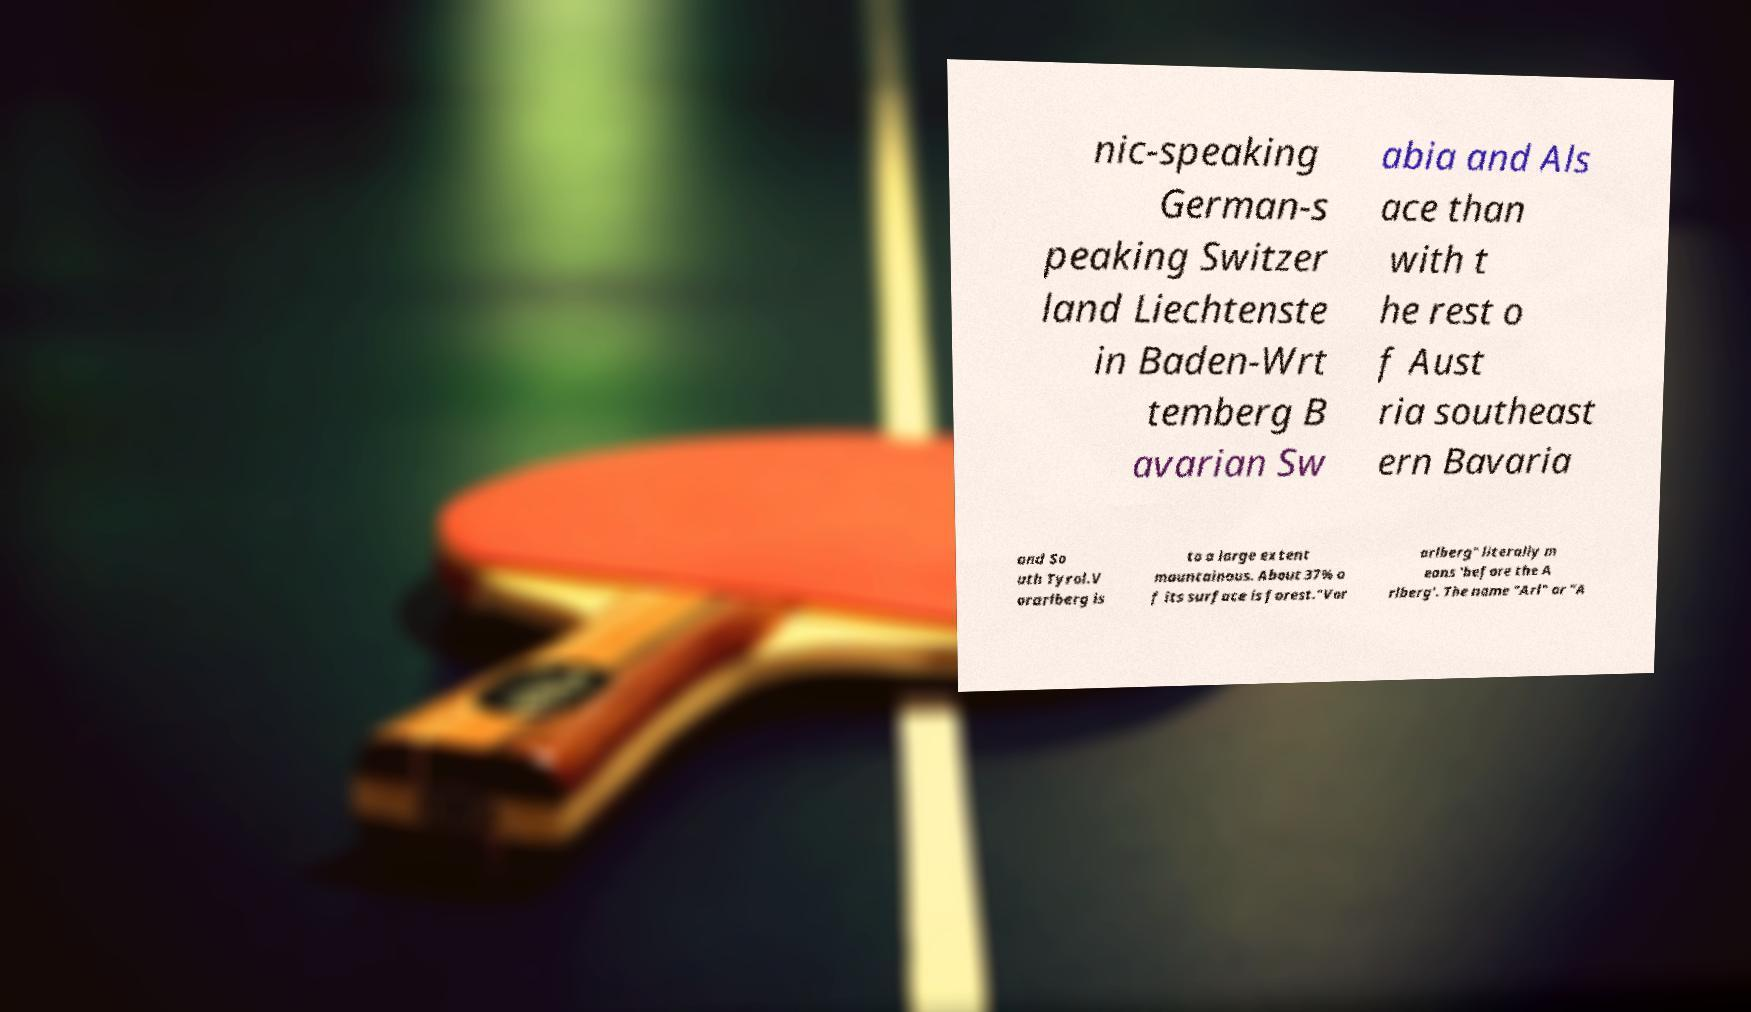Please read and relay the text visible in this image. What does it say? nic-speaking German-s peaking Switzer land Liechtenste in Baden-Wrt temberg B avarian Sw abia and Als ace than with t he rest o f Aust ria southeast ern Bavaria and So uth Tyrol.V orarlberg is to a large extent mountainous. About 37% o f its surface is forest."Vor arlberg" literally m eans 'before the A rlberg'. The name "Arl" or "A 